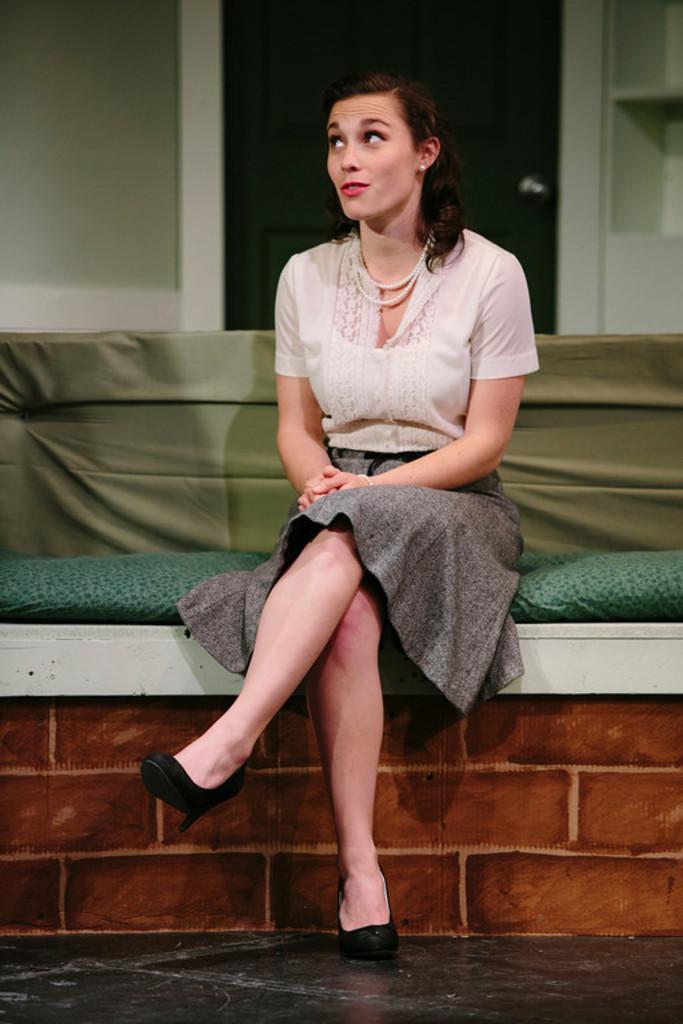Please provide a concise description of this image. There is a woman in white color shirt, sitting on a bench. In the background, there are shelves. 